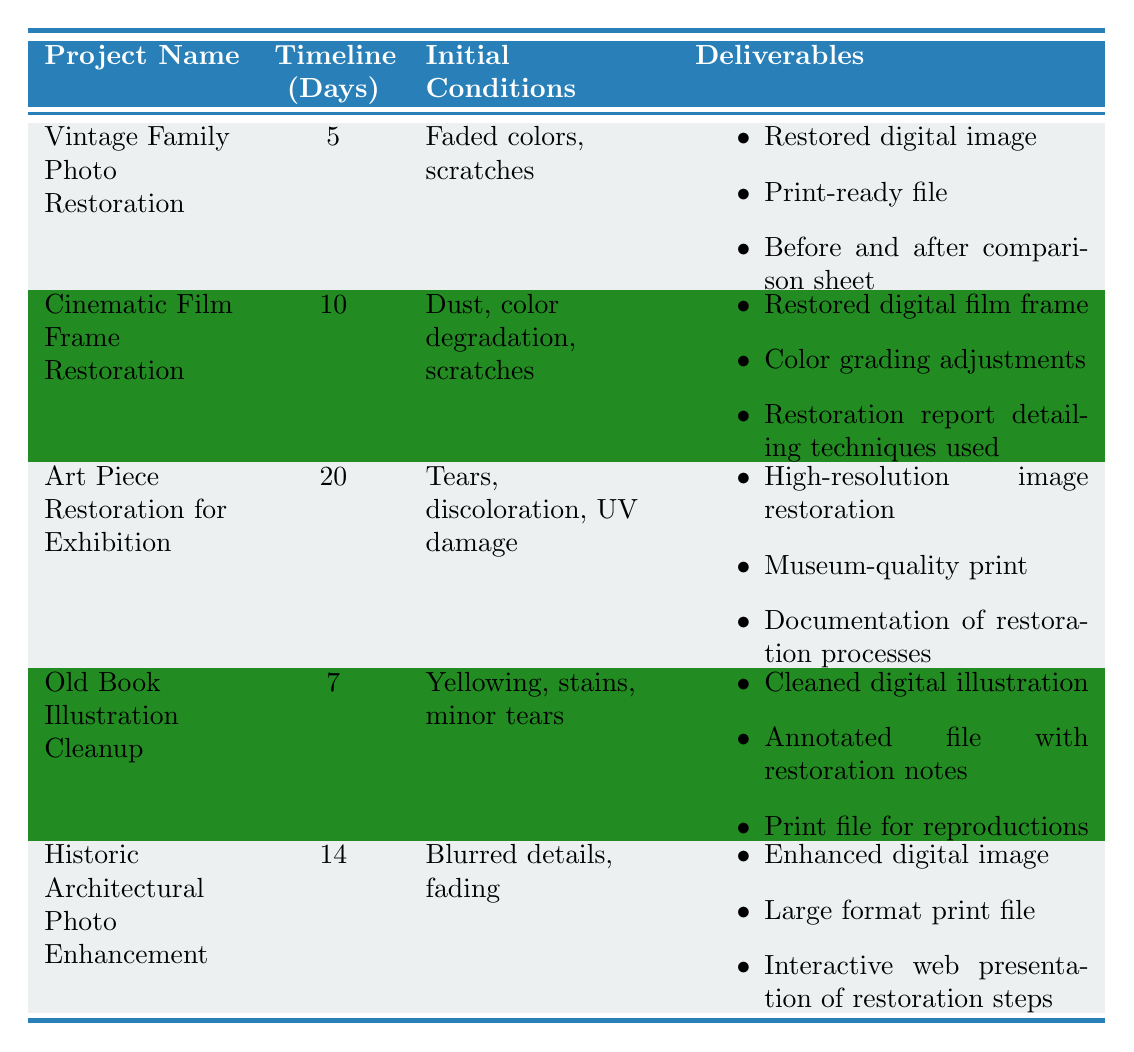What is the timeline for the Vintage Family Photo Restoration project? The table lists the timeline for the Vintage Family Photo Restoration project in the second column, which states it is 5 days.
Answer: 5 days What are the initial conditions for the Art Piece Restoration for Exhibition? The initial conditions for the Art Piece Restoration for Exhibition are found in the third column of the table, and it indicates "Tears, discoloration, UV damage."
Answer: Tears, discoloration, UV damage Which project requires the longest timeline? To determine which project requires the longest timeline, we can compare the timeline days for all projects listed. The longest one is for the Art Piece Restoration for Exhibition at 20 days.
Answer: Art Piece Restoration for Exhibition Is the Old Book Illustration Cleanup project completed in less than 10 days? The table indicates that the Old Book Illustration Cleanup has a timeline of 7 days, which is indeed less than 10 days.
Answer: Yes What is the total number of days required for the Vintage Family Photo Restoration and the Old Book Illustration Cleanup projects combined? To find the total number of days for these projects, we take the timeline of each. The Vintage Family Photo Restoration takes 5 days and the Old Book Illustration Cleanup takes 7 days, totaling 5 + 7 = 12 days.
Answer: 12 days How many projects involve restoration reports as a deliverable? By reviewing the deliverables in the last column, only the Cinematic Film Frame Restoration and the Art Piece Restoration for Exhibition have a restoration report (the specific mention of reports is needed); thus, there are two projects.
Answer: 2 projects What is the difference in timeline days between the Cinematic Film Frame Restoration and the Historic Architectural Photo Enhancement projects? The timeline for the Cinematic Film Frame Restoration is 10 days, while the Historic Architectural Photo Enhancement has a timeline of 14 days. The difference is 14 - 10 = 4 days.
Answer: 4 days Which project has the highest number of deliverables? Looking at the deliverables, the Art Piece Restoration for Exhibition offers three deliverables, the same as the other projects; however, the total number of distinct deliverables does not increase beyond that across projects, each is consistently at three differing deliverables.
Answer: All have three deliverables Is there a project that deals with color degradation as an initial condition? The table lists the Cinematic Film Frame Restoration project with initial conditions that mention "color degradation," confirming that such a project does indeed exist.
Answer: Yes 